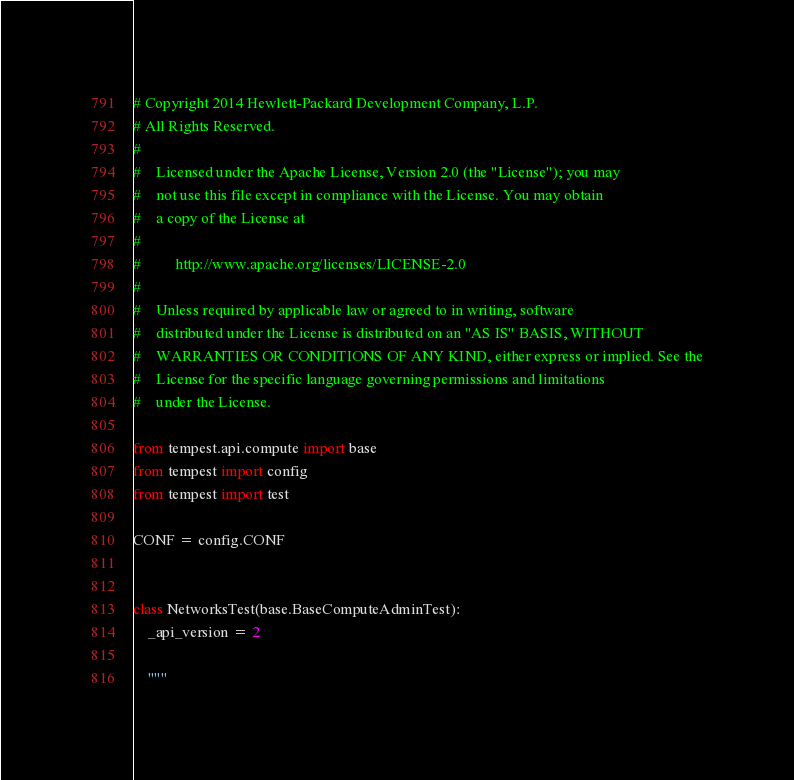Convert code to text. <code><loc_0><loc_0><loc_500><loc_500><_Python_># Copyright 2014 Hewlett-Packard Development Company, L.P.
# All Rights Reserved.
#
#    Licensed under the Apache License, Version 2.0 (the "License"); you may
#    not use this file except in compliance with the License. You may obtain
#    a copy of the License at
#
#         http://www.apache.org/licenses/LICENSE-2.0
#
#    Unless required by applicable law or agreed to in writing, software
#    distributed under the License is distributed on an "AS IS" BASIS, WITHOUT
#    WARRANTIES OR CONDITIONS OF ANY KIND, either express or implied. See the
#    License for the specific language governing permissions and limitations
#    under the License.

from tempest.api.compute import base
from tempest import config
from tempest import test

CONF = config.CONF


class NetworksTest(base.BaseComputeAdminTest):
    _api_version = 2

    """</code> 